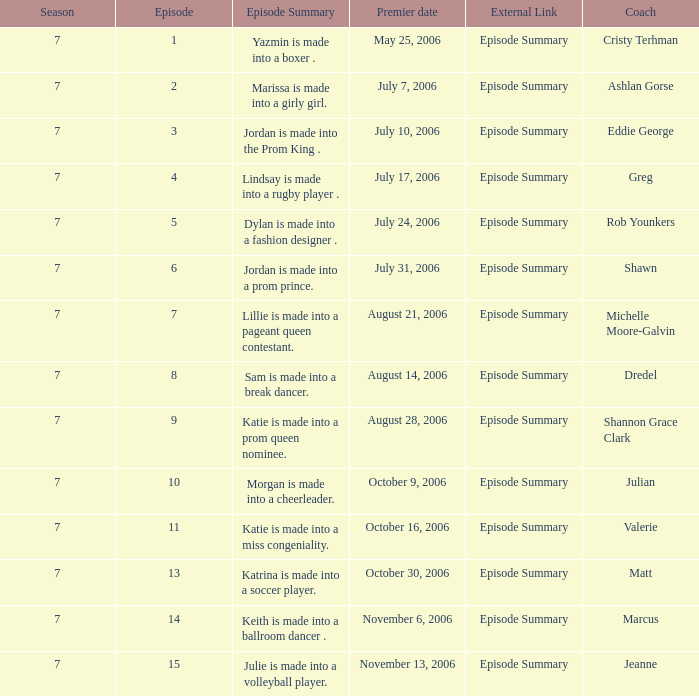What is the newest season? 7.0. 